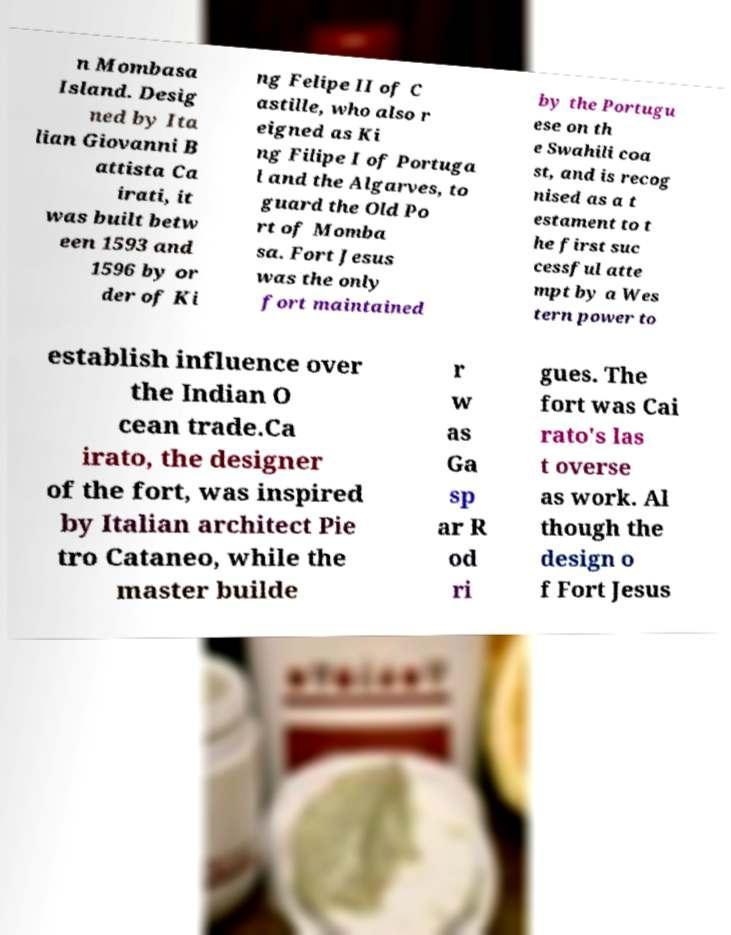What messages or text are displayed in this image? I need them in a readable, typed format. n Mombasa Island. Desig ned by Ita lian Giovanni B attista Ca irati, it was built betw een 1593 and 1596 by or der of Ki ng Felipe II of C astille, who also r eigned as Ki ng Filipe I of Portuga l and the Algarves, to guard the Old Po rt of Momba sa. Fort Jesus was the only fort maintained by the Portugu ese on th e Swahili coa st, and is recog nised as a t estament to t he first suc cessful atte mpt by a Wes tern power to establish influence over the Indian O cean trade.Ca irato, the designer of the fort, was inspired by Italian architect Pie tro Cataneo, while the master builde r w as Ga sp ar R od ri gues. The fort was Cai rato's las t overse as work. Al though the design o f Fort Jesus 